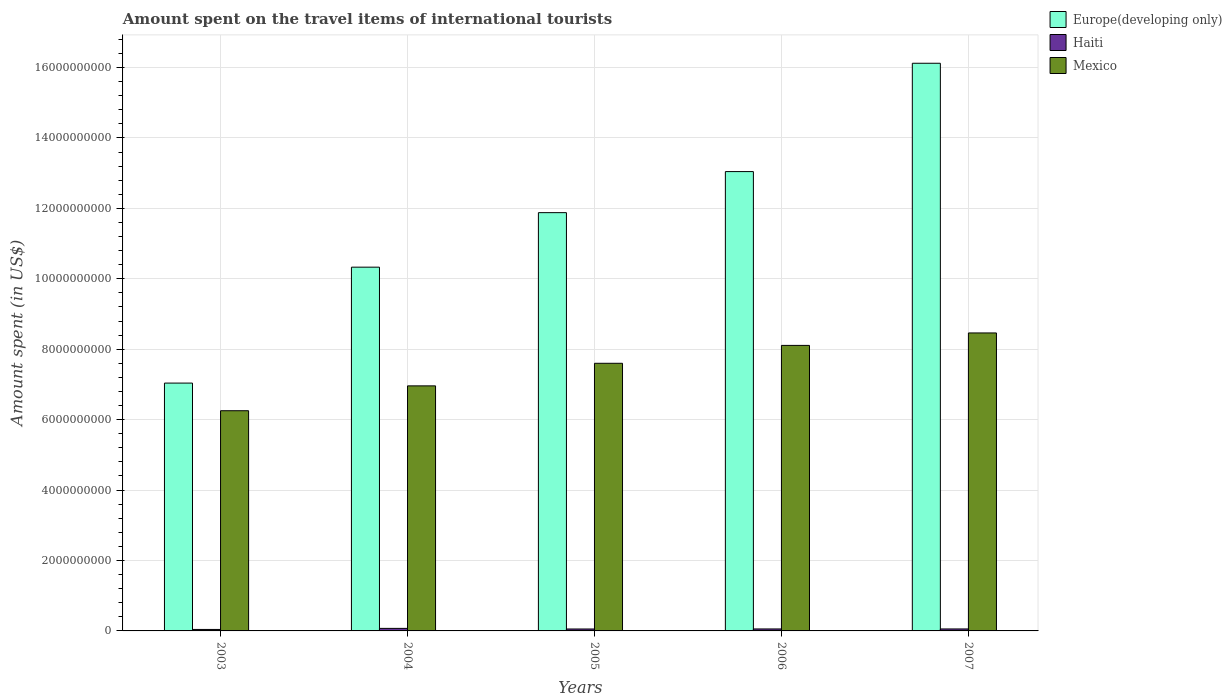How many different coloured bars are there?
Offer a very short reply. 3. Are the number of bars per tick equal to the number of legend labels?
Provide a succinct answer. Yes. What is the label of the 1st group of bars from the left?
Provide a succinct answer. 2003. What is the amount spent on the travel items of international tourists in Mexico in 2007?
Provide a succinct answer. 8.46e+09. Across all years, what is the maximum amount spent on the travel items of international tourists in Haiti?
Provide a short and direct response. 7.20e+07. Across all years, what is the minimum amount spent on the travel items of international tourists in Mexico?
Offer a very short reply. 6.25e+09. In which year was the amount spent on the travel items of international tourists in Haiti maximum?
Your answer should be very brief. 2004. In which year was the amount spent on the travel items of international tourists in Mexico minimum?
Provide a succinct answer. 2003. What is the total amount spent on the travel items of international tourists in Mexico in the graph?
Provide a succinct answer. 3.74e+1. What is the difference between the amount spent on the travel items of international tourists in Europe(developing only) in 2005 and that in 2007?
Your response must be concise. -4.24e+09. What is the difference between the amount spent on the travel items of international tourists in Mexico in 2007 and the amount spent on the travel items of international tourists in Europe(developing only) in 2005?
Your answer should be compact. -3.42e+09. What is the average amount spent on the travel items of international tourists in Europe(developing only) per year?
Ensure brevity in your answer.  1.17e+1. In the year 2006, what is the difference between the amount spent on the travel items of international tourists in Europe(developing only) and amount spent on the travel items of international tourists in Haiti?
Make the answer very short. 1.30e+1. What is the ratio of the amount spent on the travel items of international tourists in Mexico in 2004 to that in 2006?
Offer a terse response. 0.86. Is the amount spent on the travel items of international tourists in Mexico in 2003 less than that in 2005?
Keep it short and to the point. Yes. Is the difference between the amount spent on the travel items of international tourists in Europe(developing only) in 2004 and 2005 greater than the difference between the amount spent on the travel items of international tourists in Haiti in 2004 and 2005?
Provide a short and direct response. No. What is the difference between the highest and the second highest amount spent on the travel items of international tourists in Europe(developing only)?
Offer a terse response. 3.08e+09. What is the difference between the highest and the lowest amount spent on the travel items of international tourists in Europe(developing only)?
Your answer should be very brief. 9.08e+09. In how many years, is the amount spent on the travel items of international tourists in Mexico greater than the average amount spent on the travel items of international tourists in Mexico taken over all years?
Your answer should be very brief. 3. Is the sum of the amount spent on the travel items of international tourists in Mexico in 2004 and 2006 greater than the maximum amount spent on the travel items of international tourists in Haiti across all years?
Provide a succinct answer. Yes. What does the 3rd bar from the left in 2003 represents?
Offer a very short reply. Mexico. What is the difference between two consecutive major ticks on the Y-axis?
Ensure brevity in your answer.  2.00e+09. Does the graph contain any zero values?
Your answer should be very brief. No. How many legend labels are there?
Provide a succinct answer. 3. What is the title of the graph?
Offer a terse response. Amount spent on the travel items of international tourists. What is the label or title of the X-axis?
Make the answer very short. Years. What is the label or title of the Y-axis?
Your response must be concise. Amount spent (in US$). What is the Amount spent (in US$) of Europe(developing only) in 2003?
Offer a terse response. 7.04e+09. What is the Amount spent (in US$) of Haiti in 2003?
Keep it short and to the point. 4.20e+07. What is the Amount spent (in US$) of Mexico in 2003?
Make the answer very short. 6.25e+09. What is the Amount spent (in US$) of Europe(developing only) in 2004?
Give a very brief answer. 1.03e+1. What is the Amount spent (in US$) in Haiti in 2004?
Provide a succinct answer. 7.20e+07. What is the Amount spent (in US$) of Mexico in 2004?
Offer a terse response. 6.96e+09. What is the Amount spent (in US$) in Europe(developing only) in 2005?
Give a very brief answer. 1.19e+1. What is the Amount spent (in US$) of Haiti in 2005?
Keep it short and to the point. 5.50e+07. What is the Amount spent (in US$) in Mexico in 2005?
Offer a very short reply. 7.60e+09. What is the Amount spent (in US$) in Europe(developing only) in 2006?
Make the answer very short. 1.30e+1. What is the Amount spent (in US$) of Haiti in 2006?
Provide a succinct answer. 5.60e+07. What is the Amount spent (in US$) of Mexico in 2006?
Your answer should be very brief. 8.11e+09. What is the Amount spent (in US$) of Europe(developing only) in 2007?
Your response must be concise. 1.61e+1. What is the Amount spent (in US$) of Haiti in 2007?
Keep it short and to the point. 5.60e+07. What is the Amount spent (in US$) in Mexico in 2007?
Ensure brevity in your answer.  8.46e+09. Across all years, what is the maximum Amount spent (in US$) in Europe(developing only)?
Offer a very short reply. 1.61e+1. Across all years, what is the maximum Amount spent (in US$) in Haiti?
Your response must be concise. 7.20e+07. Across all years, what is the maximum Amount spent (in US$) of Mexico?
Keep it short and to the point. 8.46e+09. Across all years, what is the minimum Amount spent (in US$) in Europe(developing only)?
Your answer should be very brief. 7.04e+09. Across all years, what is the minimum Amount spent (in US$) in Haiti?
Your answer should be compact. 4.20e+07. Across all years, what is the minimum Amount spent (in US$) in Mexico?
Give a very brief answer. 6.25e+09. What is the total Amount spent (in US$) of Europe(developing only) in the graph?
Offer a terse response. 5.84e+1. What is the total Amount spent (in US$) of Haiti in the graph?
Your response must be concise. 2.81e+08. What is the total Amount spent (in US$) of Mexico in the graph?
Provide a succinct answer. 3.74e+1. What is the difference between the Amount spent (in US$) in Europe(developing only) in 2003 and that in 2004?
Your response must be concise. -3.29e+09. What is the difference between the Amount spent (in US$) in Haiti in 2003 and that in 2004?
Offer a terse response. -3.00e+07. What is the difference between the Amount spent (in US$) in Mexico in 2003 and that in 2004?
Offer a very short reply. -7.06e+08. What is the difference between the Amount spent (in US$) in Europe(developing only) in 2003 and that in 2005?
Provide a short and direct response. -4.84e+09. What is the difference between the Amount spent (in US$) of Haiti in 2003 and that in 2005?
Make the answer very short. -1.30e+07. What is the difference between the Amount spent (in US$) of Mexico in 2003 and that in 2005?
Your answer should be compact. -1.35e+09. What is the difference between the Amount spent (in US$) in Europe(developing only) in 2003 and that in 2006?
Your answer should be compact. -6.01e+09. What is the difference between the Amount spent (in US$) of Haiti in 2003 and that in 2006?
Keep it short and to the point. -1.40e+07. What is the difference between the Amount spent (in US$) in Mexico in 2003 and that in 2006?
Keep it short and to the point. -1.86e+09. What is the difference between the Amount spent (in US$) in Europe(developing only) in 2003 and that in 2007?
Offer a terse response. -9.08e+09. What is the difference between the Amount spent (in US$) in Haiti in 2003 and that in 2007?
Make the answer very short. -1.40e+07. What is the difference between the Amount spent (in US$) of Mexico in 2003 and that in 2007?
Ensure brevity in your answer.  -2.21e+09. What is the difference between the Amount spent (in US$) of Europe(developing only) in 2004 and that in 2005?
Ensure brevity in your answer.  -1.55e+09. What is the difference between the Amount spent (in US$) of Haiti in 2004 and that in 2005?
Provide a short and direct response. 1.70e+07. What is the difference between the Amount spent (in US$) in Mexico in 2004 and that in 2005?
Make the answer very short. -6.41e+08. What is the difference between the Amount spent (in US$) in Europe(developing only) in 2004 and that in 2006?
Offer a very short reply. -2.71e+09. What is the difference between the Amount spent (in US$) of Haiti in 2004 and that in 2006?
Your response must be concise. 1.60e+07. What is the difference between the Amount spent (in US$) in Mexico in 2004 and that in 2006?
Your answer should be very brief. -1.15e+09. What is the difference between the Amount spent (in US$) in Europe(developing only) in 2004 and that in 2007?
Your answer should be very brief. -5.79e+09. What is the difference between the Amount spent (in US$) of Haiti in 2004 and that in 2007?
Offer a terse response. 1.60e+07. What is the difference between the Amount spent (in US$) of Mexico in 2004 and that in 2007?
Ensure brevity in your answer.  -1.50e+09. What is the difference between the Amount spent (in US$) of Europe(developing only) in 2005 and that in 2006?
Offer a very short reply. -1.17e+09. What is the difference between the Amount spent (in US$) of Mexico in 2005 and that in 2006?
Your answer should be very brief. -5.08e+08. What is the difference between the Amount spent (in US$) in Europe(developing only) in 2005 and that in 2007?
Offer a very short reply. -4.24e+09. What is the difference between the Amount spent (in US$) of Mexico in 2005 and that in 2007?
Your answer should be compact. -8.62e+08. What is the difference between the Amount spent (in US$) in Europe(developing only) in 2006 and that in 2007?
Make the answer very short. -3.08e+09. What is the difference between the Amount spent (in US$) in Haiti in 2006 and that in 2007?
Provide a succinct answer. 0. What is the difference between the Amount spent (in US$) in Mexico in 2006 and that in 2007?
Your answer should be very brief. -3.54e+08. What is the difference between the Amount spent (in US$) of Europe(developing only) in 2003 and the Amount spent (in US$) of Haiti in 2004?
Your answer should be very brief. 6.97e+09. What is the difference between the Amount spent (in US$) of Europe(developing only) in 2003 and the Amount spent (in US$) of Mexico in 2004?
Provide a short and direct response. 7.88e+07. What is the difference between the Amount spent (in US$) of Haiti in 2003 and the Amount spent (in US$) of Mexico in 2004?
Your response must be concise. -6.92e+09. What is the difference between the Amount spent (in US$) of Europe(developing only) in 2003 and the Amount spent (in US$) of Haiti in 2005?
Your response must be concise. 6.98e+09. What is the difference between the Amount spent (in US$) in Europe(developing only) in 2003 and the Amount spent (in US$) in Mexico in 2005?
Your answer should be compact. -5.62e+08. What is the difference between the Amount spent (in US$) of Haiti in 2003 and the Amount spent (in US$) of Mexico in 2005?
Offer a terse response. -7.56e+09. What is the difference between the Amount spent (in US$) of Europe(developing only) in 2003 and the Amount spent (in US$) of Haiti in 2006?
Offer a very short reply. 6.98e+09. What is the difference between the Amount spent (in US$) of Europe(developing only) in 2003 and the Amount spent (in US$) of Mexico in 2006?
Ensure brevity in your answer.  -1.07e+09. What is the difference between the Amount spent (in US$) of Haiti in 2003 and the Amount spent (in US$) of Mexico in 2006?
Make the answer very short. -8.07e+09. What is the difference between the Amount spent (in US$) of Europe(developing only) in 2003 and the Amount spent (in US$) of Haiti in 2007?
Ensure brevity in your answer.  6.98e+09. What is the difference between the Amount spent (in US$) in Europe(developing only) in 2003 and the Amount spent (in US$) in Mexico in 2007?
Provide a short and direct response. -1.42e+09. What is the difference between the Amount spent (in US$) in Haiti in 2003 and the Amount spent (in US$) in Mexico in 2007?
Your response must be concise. -8.42e+09. What is the difference between the Amount spent (in US$) of Europe(developing only) in 2004 and the Amount spent (in US$) of Haiti in 2005?
Your response must be concise. 1.03e+1. What is the difference between the Amount spent (in US$) of Europe(developing only) in 2004 and the Amount spent (in US$) of Mexico in 2005?
Your answer should be very brief. 2.73e+09. What is the difference between the Amount spent (in US$) of Haiti in 2004 and the Amount spent (in US$) of Mexico in 2005?
Keep it short and to the point. -7.53e+09. What is the difference between the Amount spent (in US$) in Europe(developing only) in 2004 and the Amount spent (in US$) in Haiti in 2006?
Provide a succinct answer. 1.03e+1. What is the difference between the Amount spent (in US$) in Europe(developing only) in 2004 and the Amount spent (in US$) in Mexico in 2006?
Keep it short and to the point. 2.22e+09. What is the difference between the Amount spent (in US$) of Haiti in 2004 and the Amount spent (in US$) of Mexico in 2006?
Provide a succinct answer. -8.04e+09. What is the difference between the Amount spent (in US$) in Europe(developing only) in 2004 and the Amount spent (in US$) in Haiti in 2007?
Offer a terse response. 1.03e+1. What is the difference between the Amount spent (in US$) of Europe(developing only) in 2004 and the Amount spent (in US$) of Mexico in 2007?
Make the answer very short. 1.87e+09. What is the difference between the Amount spent (in US$) in Haiti in 2004 and the Amount spent (in US$) in Mexico in 2007?
Ensure brevity in your answer.  -8.39e+09. What is the difference between the Amount spent (in US$) of Europe(developing only) in 2005 and the Amount spent (in US$) of Haiti in 2006?
Provide a short and direct response. 1.18e+1. What is the difference between the Amount spent (in US$) of Europe(developing only) in 2005 and the Amount spent (in US$) of Mexico in 2006?
Your response must be concise. 3.77e+09. What is the difference between the Amount spent (in US$) of Haiti in 2005 and the Amount spent (in US$) of Mexico in 2006?
Give a very brief answer. -8.05e+09. What is the difference between the Amount spent (in US$) of Europe(developing only) in 2005 and the Amount spent (in US$) of Haiti in 2007?
Your answer should be compact. 1.18e+1. What is the difference between the Amount spent (in US$) of Europe(developing only) in 2005 and the Amount spent (in US$) of Mexico in 2007?
Give a very brief answer. 3.42e+09. What is the difference between the Amount spent (in US$) in Haiti in 2005 and the Amount spent (in US$) in Mexico in 2007?
Provide a short and direct response. -8.41e+09. What is the difference between the Amount spent (in US$) of Europe(developing only) in 2006 and the Amount spent (in US$) of Haiti in 2007?
Your response must be concise. 1.30e+1. What is the difference between the Amount spent (in US$) in Europe(developing only) in 2006 and the Amount spent (in US$) in Mexico in 2007?
Your answer should be very brief. 4.58e+09. What is the difference between the Amount spent (in US$) of Haiti in 2006 and the Amount spent (in US$) of Mexico in 2007?
Offer a very short reply. -8.41e+09. What is the average Amount spent (in US$) of Europe(developing only) per year?
Provide a succinct answer. 1.17e+1. What is the average Amount spent (in US$) of Haiti per year?
Ensure brevity in your answer.  5.62e+07. What is the average Amount spent (in US$) in Mexico per year?
Offer a very short reply. 7.48e+09. In the year 2003, what is the difference between the Amount spent (in US$) in Europe(developing only) and Amount spent (in US$) in Haiti?
Provide a succinct answer. 7.00e+09. In the year 2003, what is the difference between the Amount spent (in US$) in Europe(developing only) and Amount spent (in US$) in Mexico?
Offer a terse response. 7.85e+08. In the year 2003, what is the difference between the Amount spent (in US$) in Haiti and Amount spent (in US$) in Mexico?
Your response must be concise. -6.21e+09. In the year 2004, what is the difference between the Amount spent (in US$) in Europe(developing only) and Amount spent (in US$) in Haiti?
Offer a terse response. 1.03e+1. In the year 2004, what is the difference between the Amount spent (in US$) in Europe(developing only) and Amount spent (in US$) in Mexico?
Give a very brief answer. 3.37e+09. In the year 2004, what is the difference between the Amount spent (in US$) of Haiti and Amount spent (in US$) of Mexico?
Your answer should be very brief. -6.89e+09. In the year 2005, what is the difference between the Amount spent (in US$) in Europe(developing only) and Amount spent (in US$) in Haiti?
Offer a terse response. 1.18e+1. In the year 2005, what is the difference between the Amount spent (in US$) in Europe(developing only) and Amount spent (in US$) in Mexico?
Your answer should be compact. 4.28e+09. In the year 2005, what is the difference between the Amount spent (in US$) of Haiti and Amount spent (in US$) of Mexico?
Your response must be concise. -7.54e+09. In the year 2006, what is the difference between the Amount spent (in US$) of Europe(developing only) and Amount spent (in US$) of Haiti?
Your answer should be compact. 1.30e+1. In the year 2006, what is the difference between the Amount spent (in US$) of Europe(developing only) and Amount spent (in US$) of Mexico?
Your answer should be very brief. 4.94e+09. In the year 2006, what is the difference between the Amount spent (in US$) of Haiti and Amount spent (in US$) of Mexico?
Provide a succinct answer. -8.05e+09. In the year 2007, what is the difference between the Amount spent (in US$) in Europe(developing only) and Amount spent (in US$) in Haiti?
Your answer should be very brief. 1.61e+1. In the year 2007, what is the difference between the Amount spent (in US$) of Europe(developing only) and Amount spent (in US$) of Mexico?
Keep it short and to the point. 7.66e+09. In the year 2007, what is the difference between the Amount spent (in US$) in Haiti and Amount spent (in US$) in Mexico?
Offer a very short reply. -8.41e+09. What is the ratio of the Amount spent (in US$) in Europe(developing only) in 2003 to that in 2004?
Provide a short and direct response. 0.68. What is the ratio of the Amount spent (in US$) in Haiti in 2003 to that in 2004?
Give a very brief answer. 0.58. What is the ratio of the Amount spent (in US$) of Mexico in 2003 to that in 2004?
Ensure brevity in your answer.  0.9. What is the ratio of the Amount spent (in US$) of Europe(developing only) in 2003 to that in 2005?
Provide a succinct answer. 0.59. What is the ratio of the Amount spent (in US$) of Haiti in 2003 to that in 2005?
Keep it short and to the point. 0.76. What is the ratio of the Amount spent (in US$) in Mexico in 2003 to that in 2005?
Make the answer very short. 0.82. What is the ratio of the Amount spent (in US$) of Europe(developing only) in 2003 to that in 2006?
Provide a succinct answer. 0.54. What is the ratio of the Amount spent (in US$) of Mexico in 2003 to that in 2006?
Keep it short and to the point. 0.77. What is the ratio of the Amount spent (in US$) in Europe(developing only) in 2003 to that in 2007?
Provide a short and direct response. 0.44. What is the ratio of the Amount spent (in US$) of Mexico in 2003 to that in 2007?
Ensure brevity in your answer.  0.74. What is the ratio of the Amount spent (in US$) in Europe(developing only) in 2004 to that in 2005?
Your answer should be compact. 0.87. What is the ratio of the Amount spent (in US$) of Haiti in 2004 to that in 2005?
Offer a terse response. 1.31. What is the ratio of the Amount spent (in US$) in Mexico in 2004 to that in 2005?
Keep it short and to the point. 0.92. What is the ratio of the Amount spent (in US$) in Europe(developing only) in 2004 to that in 2006?
Provide a short and direct response. 0.79. What is the ratio of the Amount spent (in US$) of Mexico in 2004 to that in 2006?
Your response must be concise. 0.86. What is the ratio of the Amount spent (in US$) of Europe(developing only) in 2004 to that in 2007?
Your answer should be very brief. 0.64. What is the ratio of the Amount spent (in US$) of Haiti in 2004 to that in 2007?
Your answer should be compact. 1.29. What is the ratio of the Amount spent (in US$) in Mexico in 2004 to that in 2007?
Ensure brevity in your answer.  0.82. What is the ratio of the Amount spent (in US$) of Europe(developing only) in 2005 to that in 2006?
Your answer should be compact. 0.91. What is the ratio of the Amount spent (in US$) of Haiti in 2005 to that in 2006?
Make the answer very short. 0.98. What is the ratio of the Amount spent (in US$) of Mexico in 2005 to that in 2006?
Your response must be concise. 0.94. What is the ratio of the Amount spent (in US$) in Europe(developing only) in 2005 to that in 2007?
Keep it short and to the point. 0.74. What is the ratio of the Amount spent (in US$) of Haiti in 2005 to that in 2007?
Provide a short and direct response. 0.98. What is the ratio of the Amount spent (in US$) of Mexico in 2005 to that in 2007?
Ensure brevity in your answer.  0.9. What is the ratio of the Amount spent (in US$) of Europe(developing only) in 2006 to that in 2007?
Keep it short and to the point. 0.81. What is the ratio of the Amount spent (in US$) of Haiti in 2006 to that in 2007?
Your answer should be very brief. 1. What is the ratio of the Amount spent (in US$) in Mexico in 2006 to that in 2007?
Offer a terse response. 0.96. What is the difference between the highest and the second highest Amount spent (in US$) of Europe(developing only)?
Your answer should be very brief. 3.08e+09. What is the difference between the highest and the second highest Amount spent (in US$) of Haiti?
Provide a succinct answer. 1.60e+07. What is the difference between the highest and the second highest Amount spent (in US$) in Mexico?
Make the answer very short. 3.54e+08. What is the difference between the highest and the lowest Amount spent (in US$) in Europe(developing only)?
Offer a very short reply. 9.08e+09. What is the difference between the highest and the lowest Amount spent (in US$) of Haiti?
Keep it short and to the point. 3.00e+07. What is the difference between the highest and the lowest Amount spent (in US$) of Mexico?
Offer a very short reply. 2.21e+09. 